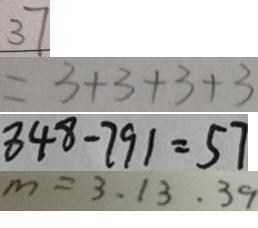<formula> <loc_0><loc_0><loc_500><loc_500>3 7 
 = 3 + 3 + 3 + 3 
 8 4 8 - 7 9 1 = 5 7 
 m = 3 . 1 3 . 3 9</formula> 